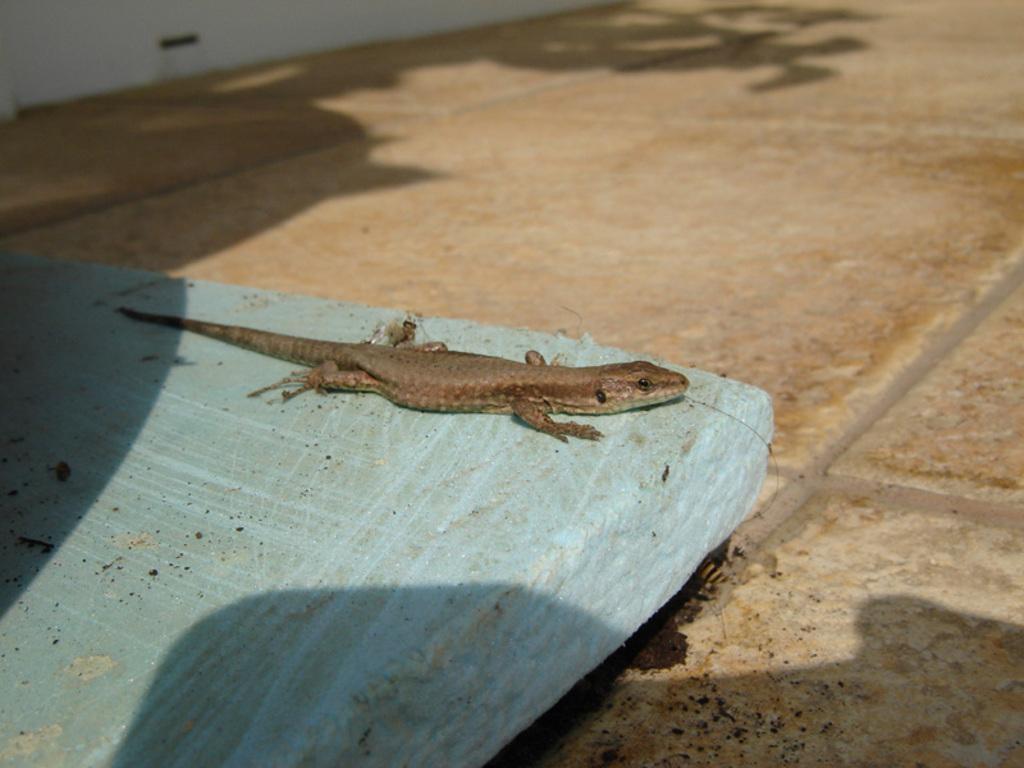Can you describe this image briefly? In this image there is a reptile on an object which is on the floor. Left top there is a wall. 